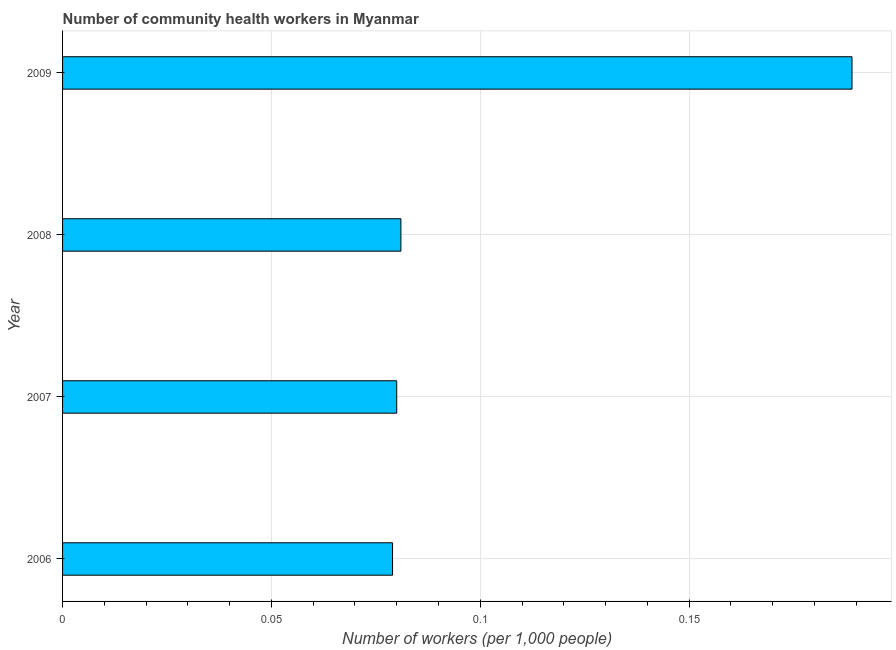Does the graph contain grids?
Your answer should be compact. Yes. What is the title of the graph?
Provide a short and direct response. Number of community health workers in Myanmar. What is the label or title of the X-axis?
Provide a short and direct response. Number of workers (per 1,0 people). What is the label or title of the Y-axis?
Keep it short and to the point. Year. What is the number of community health workers in 2007?
Provide a short and direct response. 0.08. Across all years, what is the maximum number of community health workers?
Your answer should be very brief. 0.19. Across all years, what is the minimum number of community health workers?
Offer a very short reply. 0.08. In which year was the number of community health workers maximum?
Keep it short and to the point. 2009. In which year was the number of community health workers minimum?
Offer a terse response. 2006. What is the sum of the number of community health workers?
Offer a terse response. 0.43. What is the difference between the number of community health workers in 2006 and 2007?
Ensure brevity in your answer.  -0. What is the average number of community health workers per year?
Your response must be concise. 0.11. What is the median number of community health workers?
Make the answer very short. 0.08. In how many years, is the number of community health workers greater than 0.15 ?
Your response must be concise. 1. Do a majority of the years between 2008 and 2007 (inclusive) have number of community health workers greater than 0.18 ?
Ensure brevity in your answer.  No. Is the difference between the number of community health workers in 2006 and 2008 greater than the difference between any two years?
Your answer should be very brief. No. What is the difference between the highest and the second highest number of community health workers?
Provide a succinct answer. 0.11. Is the sum of the number of community health workers in 2006 and 2007 greater than the maximum number of community health workers across all years?
Make the answer very short. No. What is the difference between the highest and the lowest number of community health workers?
Provide a succinct answer. 0.11. In how many years, is the number of community health workers greater than the average number of community health workers taken over all years?
Ensure brevity in your answer.  1. How many bars are there?
Your response must be concise. 4. Are all the bars in the graph horizontal?
Offer a terse response. Yes. What is the difference between two consecutive major ticks on the X-axis?
Make the answer very short. 0.05. What is the Number of workers (per 1,000 people) of 2006?
Your response must be concise. 0.08. What is the Number of workers (per 1,000 people) in 2007?
Ensure brevity in your answer.  0.08. What is the Number of workers (per 1,000 people) in 2008?
Keep it short and to the point. 0.08. What is the Number of workers (per 1,000 people) of 2009?
Give a very brief answer. 0.19. What is the difference between the Number of workers (per 1,000 people) in 2006 and 2007?
Offer a very short reply. -0. What is the difference between the Number of workers (per 1,000 people) in 2006 and 2008?
Offer a very short reply. -0. What is the difference between the Number of workers (per 1,000 people) in 2006 and 2009?
Your answer should be very brief. -0.11. What is the difference between the Number of workers (per 1,000 people) in 2007 and 2008?
Provide a succinct answer. -0. What is the difference between the Number of workers (per 1,000 people) in 2007 and 2009?
Keep it short and to the point. -0.11. What is the difference between the Number of workers (per 1,000 people) in 2008 and 2009?
Provide a succinct answer. -0.11. What is the ratio of the Number of workers (per 1,000 people) in 2006 to that in 2009?
Give a very brief answer. 0.42. What is the ratio of the Number of workers (per 1,000 people) in 2007 to that in 2008?
Offer a very short reply. 0.99. What is the ratio of the Number of workers (per 1,000 people) in 2007 to that in 2009?
Keep it short and to the point. 0.42. What is the ratio of the Number of workers (per 1,000 people) in 2008 to that in 2009?
Provide a succinct answer. 0.43. 